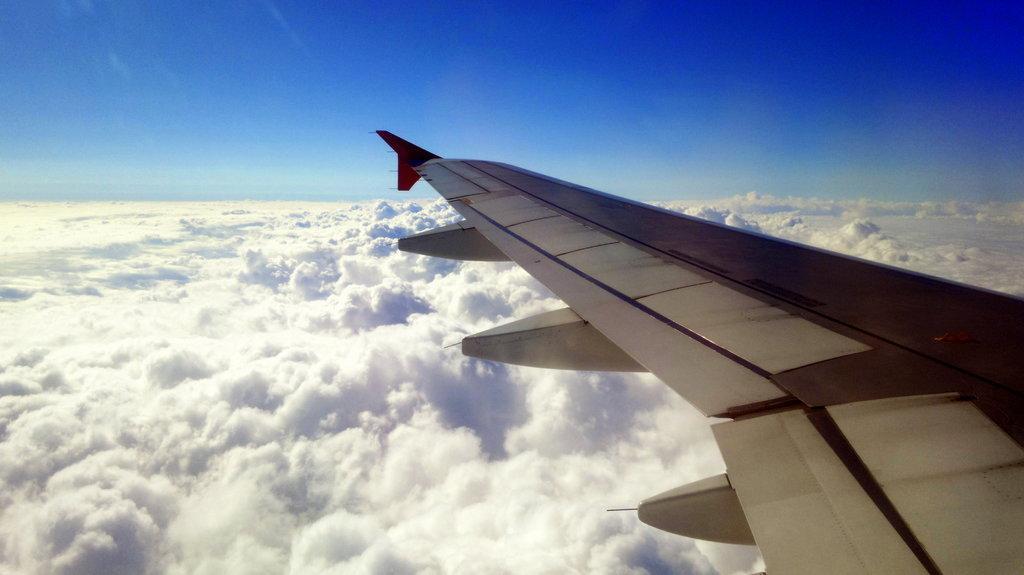Please provide a concise description of this image. On the right side there is a wing of a flight. Near to that there are clouds and sky. 